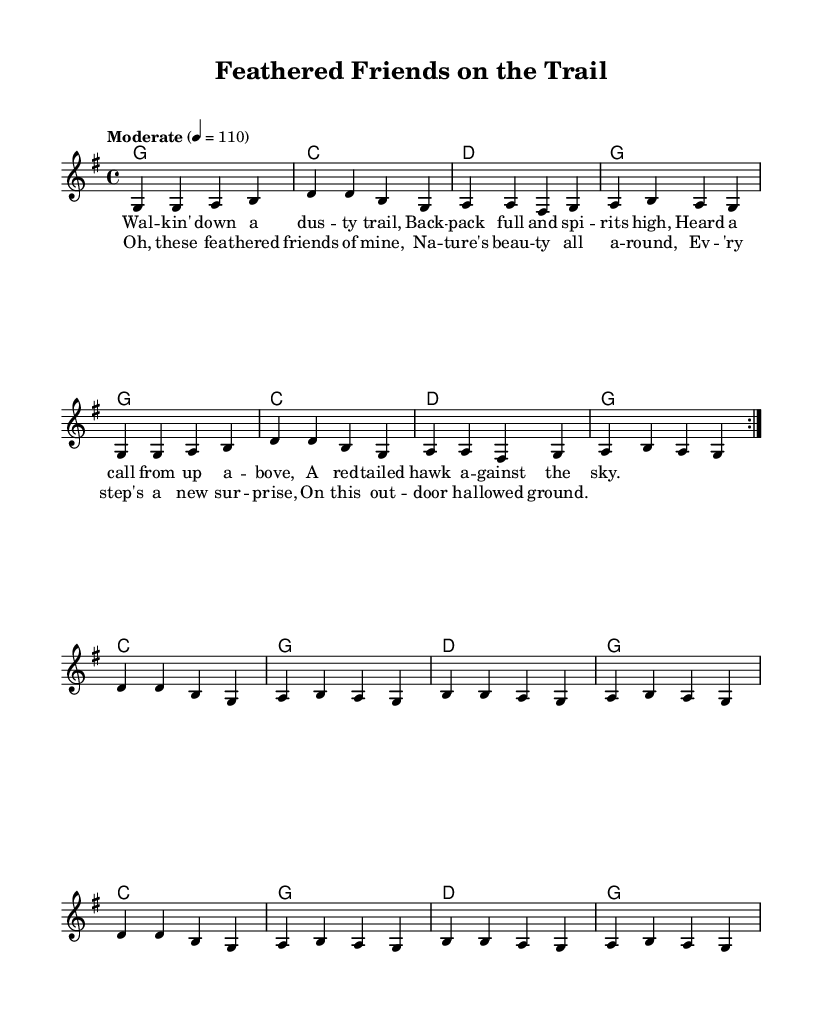What is the key signature of this music? The key signature is G major, which has one sharp (F#). You can identify the key signature at the beginning of the staff, where it shows one sharp on the top line of the treble clef.
Answer: G major What is the time signature of this music? The time signature is 4/4. It can be found at the beginning of the staff, where it indicates four beats in each measure and the quarter note gets one beat.
Answer: 4/4 What is the tempo marking of this music? The tempo marking is "Moderate" with a metronome mark of 110 beats per minute. This is indicated near the beginning of the piece, which specifies the speed of the music.
Answer: Moderate, 110 How many sections does the song have based on the structure? The song has three sections: an introduction, a verse, and a chorus. You can determine this by looking for the distinct lyrics and repeated melody lines labeled as verse and chorus in the sheet music.
Answer: Three What instrument is primarily notated in this sheet music? The primary instrument notated is the voice, specifically indicated by the use of "new Voice" in the score components. The melody is intended for vocal performance and is notated in the treble clef.
Answer: Voice How many times is the first melody section repeated? The first melody section is repeated twice, as indicated by the “\repeat volta 2” command in the melody section of the code, showing it is to be played two times.
Answer: Two 